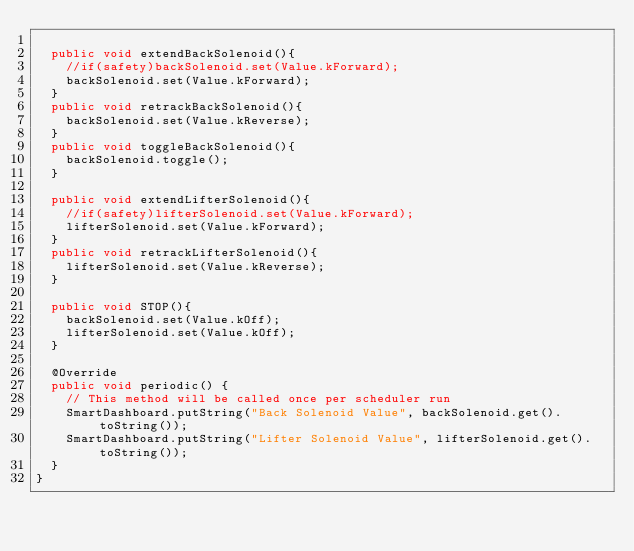Convert code to text. <code><loc_0><loc_0><loc_500><loc_500><_Java_>
  public void extendBackSolenoid(){
    //if(safety)backSolenoid.set(Value.kForward);
    backSolenoid.set(Value.kForward);
  }
  public void retrackBackSolenoid(){
    backSolenoid.set(Value.kReverse);
  }
  public void toggleBackSolenoid(){
    backSolenoid.toggle();
  }

  public void extendLifterSolenoid(){
    //if(safety)lifterSolenoid.set(Value.kForward);
    lifterSolenoid.set(Value.kForward);
  }
  public void retrackLifterSolenoid(){
    lifterSolenoid.set(Value.kReverse);
  }

  public void STOP(){
    backSolenoid.set(Value.kOff);
    lifterSolenoid.set(Value.kOff);
  }

  @Override
  public void periodic() {
    // This method will be called once per scheduler run
    SmartDashboard.putString("Back Solenoid Value", backSolenoid.get().toString());
    SmartDashboard.putString("Lifter Solenoid Value", lifterSolenoid.get().toString());
  }
}
</code> 